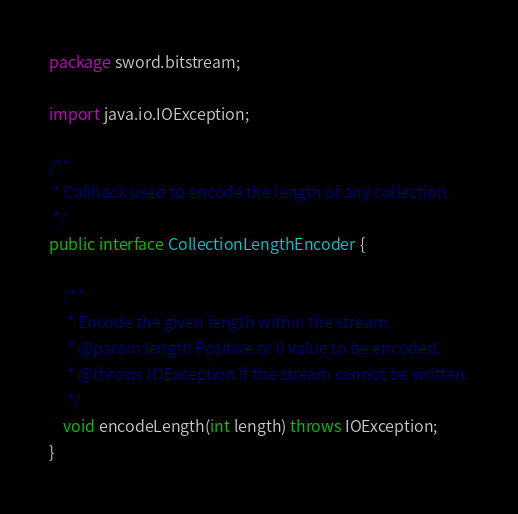<code> <loc_0><loc_0><loc_500><loc_500><_Java_>package sword.bitstream;

import java.io.IOException;

/**
 * Callback used to encode the length of any collection.
 */
public interface CollectionLengthEncoder {

    /**
     * Encode the given length within the stream.
     * @param length Positive or 0 value to be encoded.
     * @throws IOException if the stream cannot be written.
     */
    void encodeLength(int length) throws IOException;
}
</code> 